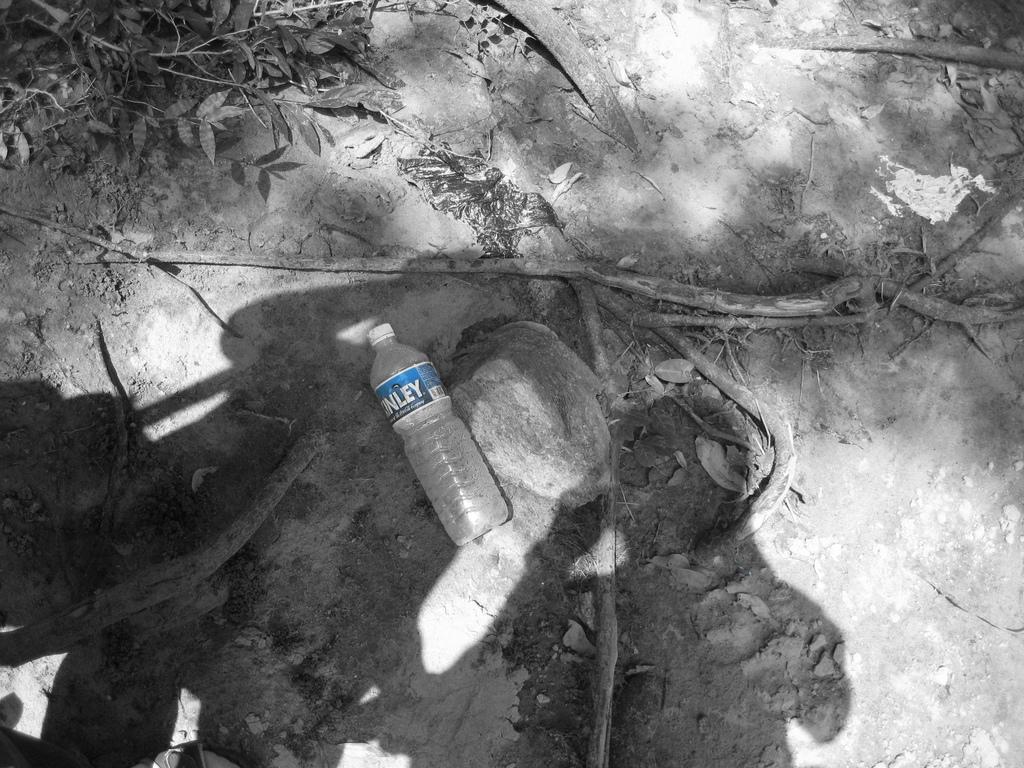How would you summarize this image in a sentence or two? In this picture there is a bottle on the floor with white colour cap. At the left side there are leaves. 